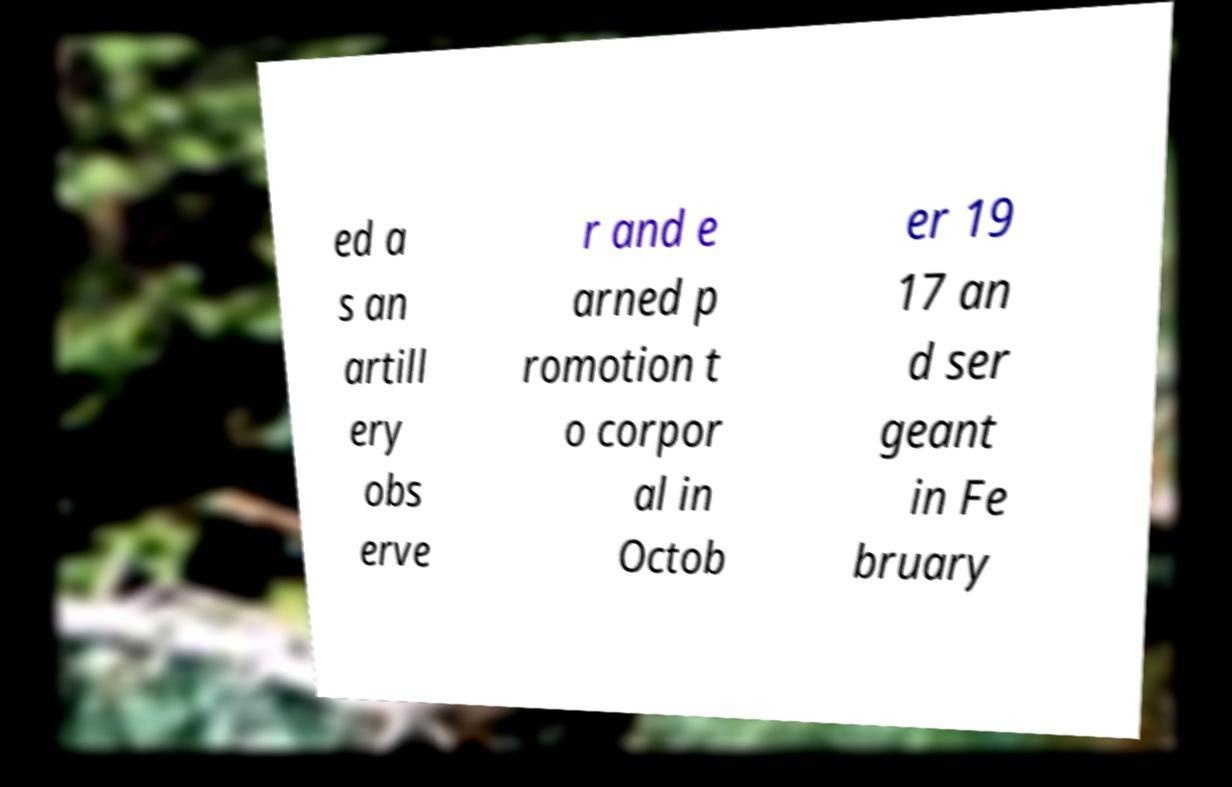What messages or text are displayed in this image? I need them in a readable, typed format. ed a s an artill ery obs erve r and e arned p romotion t o corpor al in Octob er 19 17 an d ser geant in Fe bruary 